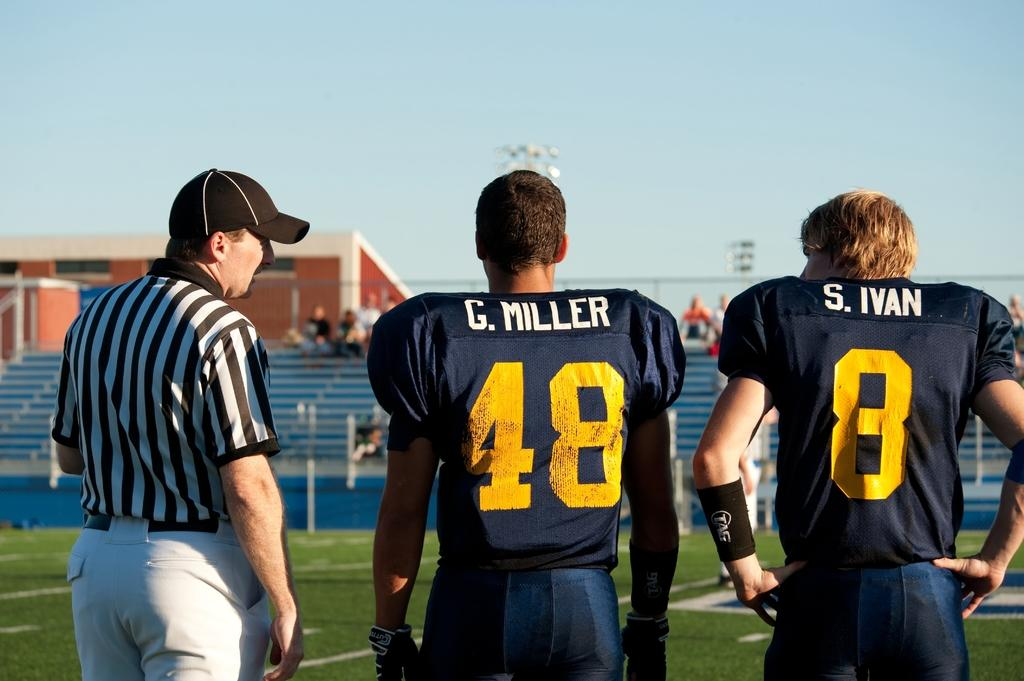Provide a one-sentence caption for the provided image. A referee talks to Miller and Ivan on the side of the field. 